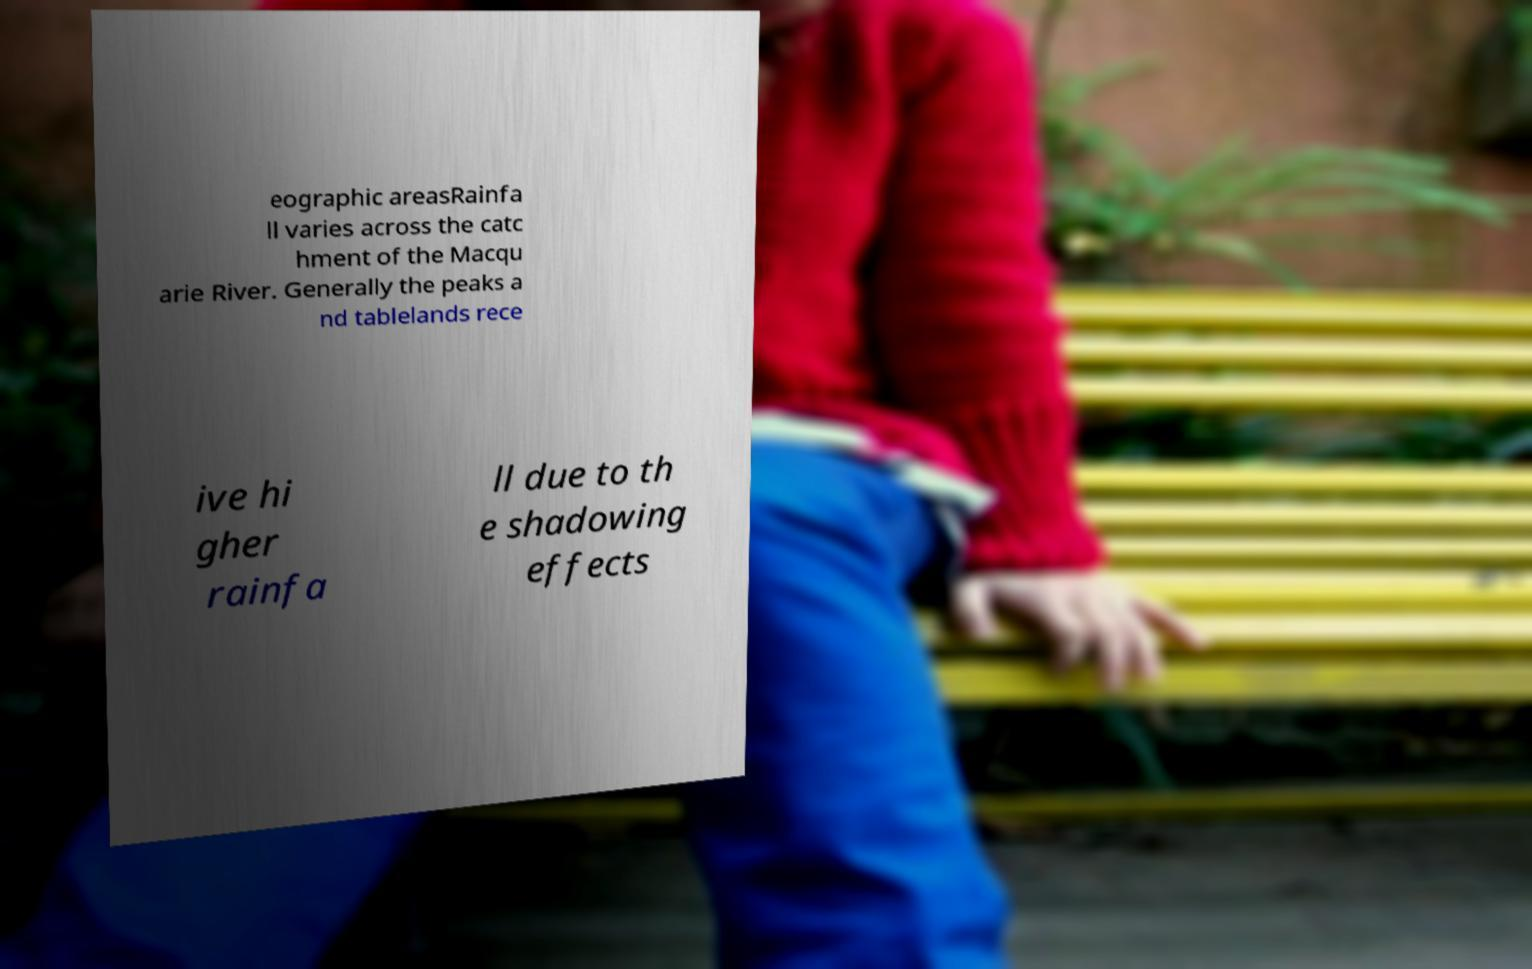Can you read and provide the text displayed in the image?This photo seems to have some interesting text. Can you extract and type it out for me? eographic areasRainfa ll varies across the catc hment of the Macqu arie River. Generally the peaks a nd tablelands rece ive hi gher rainfa ll due to th e shadowing effects 